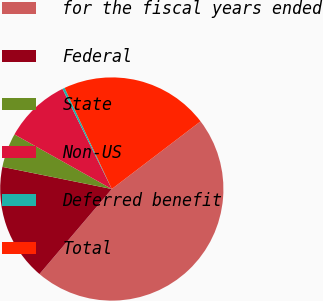Convert chart. <chart><loc_0><loc_0><loc_500><loc_500><pie_chart><fcel>for the fiscal years ended<fcel>Federal<fcel>State<fcel>Non-US<fcel>Deferred benefit<fcel>Total<nl><fcel>46.58%<fcel>16.96%<fcel>4.96%<fcel>9.58%<fcel>0.33%<fcel>21.59%<nl></chart> 